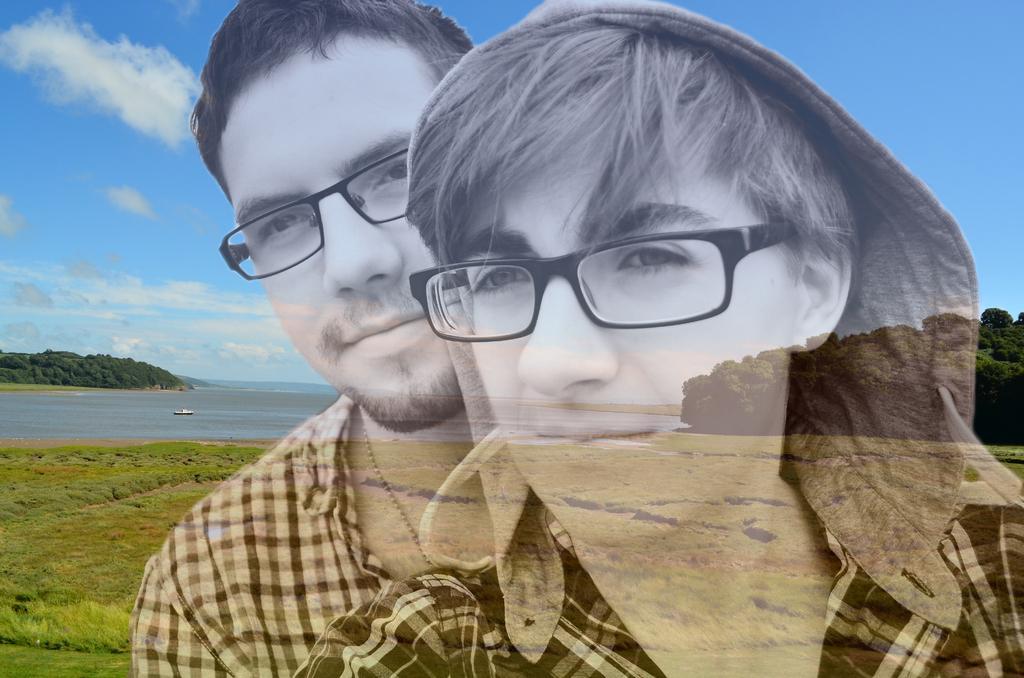Describe this image in one or two sentences. Here we can see two persons and they wore spectacles. Here we can see grass, water, and trees. In the background there is sky with clouds. 